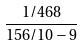<formula> <loc_0><loc_0><loc_500><loc_500>\frac { 1 / 4 6 8 } { 1 5 6 / 1 0 - 9 }</formula> 